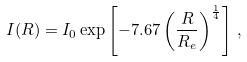<formula> <loc_0><loc_0><loc_500><loc_500>I ( R ) = I _ { 0 } \exp \left [ - 7 . 6 7 \left ( \frac { R } { R _ { e } } \right ) ^ { \frac { 1 } { 4 } } \right ] \, ,</formula> 